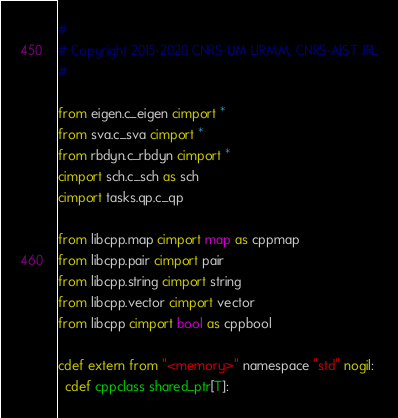<code> <loc_0><loc_0><loc_500><loc_500><_Cython_>#
# Copyright 2015-2020 CNRS-UM LIRMM, CNRS-AIST JRL
#

from eigen.c_eigen cimport *
from sva.c_sva cimport *
from rbdyn.c_rbdyn cimport *
cimport sch.c_sch as sch
cimport tasks.qp.c_qp

from libcpp.map cimport map as cppmap
from libcpp.pair cimport pair
from libcpp.string cimport string
from libcpp.vector cimport vector
from libcpp cimport bool as cppbool

cdef extern from "<memory>" namespace "std" nogil:
  cdef cppclass shared_ptr[T]:</code> 